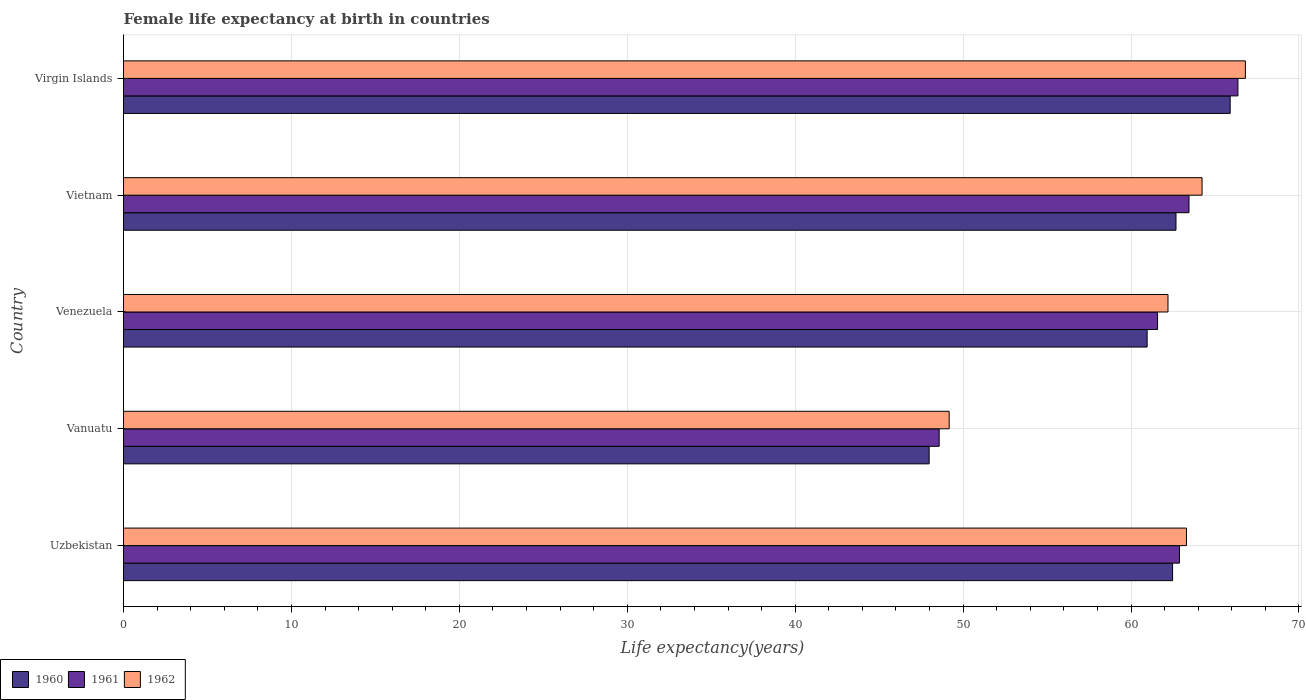How many different coloured bars are there?
Ensure brevity in your answer.  3. Are the number of bars per tick equal to the number of legend labels?
Offer a terse response. Yes. How many bars are there on the 3rd tick from the top?
Provide a short and direct response. 3. What is the label of the 1st group of bars from the top?
Offer a very short reply. Virgin Islands. What is the female life expectancy at birth in 1960 in Uzbekistan?
Make the answer very short. 62.48. Across all countries, what is the maximum female life expectancy at birth in 1962?
Give a very brief answer. 66.81. Across all countries, what is the minimum female life expectancy at birth in 1962?
Your response must be concise. 49.17. In which country was the female life expectancy at birth in 1960 maximum?
Offer a very short reply. Virgin Islands. In which country was the female life expectancy at birth in 1960 minimum?
Your answer should be very brief. Vanuatu. What is the total female life expectancy at birth in 1962 in the graph?
Your answer should be very brief. 305.72. What is the difference between the female life expectancy at birth in 1960 in Uzbekistan and that in Vanuatu?
Your response must be concise. 14.5. What is the difference between the female life expectancy at birth in 1961 in Vietnam and the female life expectancy at birth in 1962 in Uzbekistan?
Provide a succinct answer. 0.15. What is the average female life expectancy at birth in 1962 per country?
Offer a terse response. 61.14. What is the difference between the female life expectancy at birth in 1960 and female life expectancy at birth in 1961 in Venezuela?
Ensure brevity in your answer.  -0.62. In how many countries, is the female life expectancy at birth in 1961 greater than 62 years?
Offer a terse response. 3. What is the ratio of the female life expectancy at birth in 1962 in Vanuatu to that in Venezuela?
Your answer should be very brief. 0.79. Is the difference between the female life expectancy at birth in 1960 in Uzbekistan and Vietnam greater than the difference between the female life expectancy at birth in 1961 in Uzbekistan and Vietnam?
Offer a terse response. Yes. What is the difference between the highest and the second highest female life expectancy at birth in 1960?
Your answer should be very brief. 3.23. What is the difference between the highest and the lowest female life expectancy at birth in 1961?
Your response must be concise. 17.79. In how many countries, is the female life expectancy at birth in 1960 greater than the average female life expectancy at birth in 1960 taken over all countries?
Make the answer very short. 4. Is the sum of the female life expectancy at birth in 1960 in Venezuela and Virgin Islands greater than the maximum female life expectancy at birth in 1962 across all countries?
Make the answer very short. Yes. What does the 3rd bar from the top in Venezuela represents?
Offer a very short reply. 1960. Is it the case that in every country, the sum of the female life expectancy at birth in 1960 and female life expectancy at birth in 1961 is greater than the female life expectancy at birth in 1962?
Make the answer very short. Yes. How many bars are there?
Provide a succinct answer. 15. Are all the bars in the graph horizontal?
Offer a terse response. Yes. Are the values on the major ticks of X-axis written in scientific E-notation?
Provide a succinct answer. No. How are the legend labels stacked?
Make the answer very short. Horizontal. What is the title of the graph?
Give a very brief answer. Female life expectancy at birth in countries. What is the label or title of the X-axis?
Provide a short and direct response. Life expectancy(years). What is the label or title of the Y-axis?
Offer a very short reply. Country. What is the Life expectancy(years) of 1960 in Uzbekistan?
Your response must be concise. 62.48. What is the Life expectancy(years) in 1961 in Uzbekistan?
Your answer should be very brief. 62.89. What is the Life expectancy(years) of 1962 in Uzbekistan?
Make the answer very short. 63.3. What is the Life expectancy(years) of 1960 in Vanuatu?
Keep it short and to the point. 47.98. What is the Life expectancy(years) of 1961 in Vanuatu?
Your answer should be very brief. 48.58. What is the Life expectancy(years) in 1962 in Vanuatu?
Give a very brief answer. 49.17. What is the Life expectancy(years) of 1960 in Venezuela?
Provide a succinct answer. 60.96. What is the Life expectancy(years) of 1961 in Venezuela?
Your response must be concise. 61.58. What is the Life expectancy(years) of 1962 in Venezuela?
Offer a very short reply. 62.2. What is the Life expectancy(years) of 1960 in Vietnam?
Ensure brevity in your answer.  62.68. What is the Life expectancy(years) in 1961 in Vietnam?
Offer a terse response. 63.45. What is the Life expectancy(years) in 1962 in Vietnam?
Provide a succinct answer. 64.23. What is the Life expectancy(years) in 1960 in Virgin Islands?
Your answer should be compact. 65.91. What is the Life expectancy(years) of 1961 in Virgin Islands?
Ensure brevity in your answer.  66.37. What is the Life expectancy(years) in 1962 in Virgin Islands?
Your response must be concise. 66.81. Across all countries, what is the maximum Life expectancy(years) in 1960?
Make the answer very short. 65.91. Across all countries, what is the maximum Life expectancy(years) in 1961?
Provide a short and direct response. 66.37. Across all countries, what is the maximum Life expectancy(years) of 1962?
Make the answer very short. 66.81. Across all countries, what is the minimum Life expectancy(years) in 1960?
Give a very brief answer. 47.98. Across all countries, what is the minimum Life expectancy(years) of 1961?
Your response must be concise. 48.58. Across all countries, what is the minimum Life expectancy(years) in 1962?
Your answer should be compact. 49.17. What is the total Life expectancy(years) of 1960 in the graph?
Ensure brevity in your answer.  300. What is the total Life expectancy(years) in 1961 in the graph?
Offer a very short reply. 302.86. What is the total Life expectancy(years) of 1962 in the graph?
Offer a terse response. 305.72. What is the difference between the Life expectancy(years) in 1960 in Uzbekistan and that in Vanuatu?
Provide a short and direct response. 14.5. What is the difference between the Life expectancy(years) of 1961 in Uzbekistan and that in Vanuatu?
Your answer should be compact. 14.31. What is the difference between the Life expectancy(years) in 1962 in Uzbekistan and that in Vanuatu?
Provide a succinct answer. 14.13. What is the difference between the Life expectancy(years) in 1960 in Uzbekistan and that in Venezuela?
Your answer should be compact. 1.51. What is the difference between the Life expectancy(years) in 1961 in Uzbekistan and that in Venezuela?
Your answer should be very brief. 1.3. What is the difference between the Life expectancy(years) in 1962 in Uzbekistan and that in Venezuela?
Your answer should be very brief. 1.1. What is the difference between the Life expectancy(years) in 1960 in Uzbekistan and that in Vietnam?
Provide a short and direct response. -0.2. What is the difference between the Life expectancy(years) in 1961 in Uzbekistan and that in Vietnam?
Your response must be concise. -0.57. What is the difference between the Life expectancy(years) of 1962 in Uzbekistan and that in Vietnam?
Provide a short and direct response. -0.93. What is the difference between the Life expectancy(years) of 1960 in Uzbekistan and that in Virgin Islands?
Offer a terse response. -3.43. What is the difference between the Life expectancy(years) of 1961 in Uzbekistan and that in Virgin Islands?
Your answer should be very brief. -3.48. What is the difference between the Life expectancy(years) in 1962 in Uzbekistan and that in Virgin Islands?
Your answer should be compact. -3.51. What is the difference between the Life expectancy(years) in 1960 in Vanuatu and that in Venezuela?
Provide a short and direct response. -12.98. What is the difference between the Life expectancy(years) of 1961 in Vanuatu and that in Venezuela?
Provide a succinct answer. -13.01. What is the difference between the Life expectancy(years) of 1962 in Vanuatu and that in Venezuela?
Keep it short and to the point. -13.03. What is the difference between the Life expectancy(years) of 1960 in Vanuatu and that in Vietnam?
Your answer should be compact. -14.7. What is the difference between the Life expectancy(years) of 1961 in Vanuatu and that in Vietnam?
Make the answer very short. -14.88. What is the difference between the Life expectancy(years) of 1962 in Vanuatu and that in Vietnam?
Offer a terse response. -15.06. What is the difference between the Life expectancy(years) of 1960 in Vanuatu and that in Virgin Islands?
Offer a terse response. -17.93. What is the difference between the Life expectancy(years) of 1961 in Vanuatu and that in Virgin Islands?
Your response must be concise. -17.79. What is the difference between the Life expectancy(years) of 1962 in Vanuatu and that in Virgin Islands?
Your response must be concise. -17.64. What is the difference between the Life expectancy(years) of 1960 in Venezuela and that in Vietnam?
Your response must be concise. -1.72. What is the difference between the Life expectancy(years) of 1961 in Venezuela and that in Vietnam?
Make the answer very short. -1.87. What is the difference between the Life expectancy(years) in 1962 in Venezuela and that in Vietnam?
Ensure brevity in your answer.  -2.03. What is the difference between the Life expectancy(years) of 1960 in Venezuela and that in Virgin Islands?
Offer a terse response. -4.95. What is the difference between the Life expectancy(years) in 1961 in Venezuela and that in Virgin Islands?
Give a very brief answer. -4.79. What is the difference between the Life expectancy(years) of 1962 in Venezuela and that in Virgin Islands?
Offer a very short reply. -4.61. What is the difference between the Life expectancy(years) of 1960 in Vietnam and that in Virgin Islands?
Provide a succinct answer. -3.23. What is the difference between the Life expectancy(years) in 1961 in Vietnam and that in Virgin Islands?
Provide a short and direct response. -2.91. What is the difference between the Life expectancy(years) in 1962 in Vietnam and that in Virgin Islands?
Make the answer very short. -2.58. What is the difference between the Life expectancy(years) in 1960 in Uzbekistan and the Life expectancy(years) in 1961 in Vanuatu?
Provide a succinct answer. 13.9. What is the difference between the Life expectancy(years) of 1960 in Uzbekistan and the Life expectancy(years) of 1962 in Vanuatu?
Your answer should be compact. 13.3. What is the difference between the Life expectancy(years) in 1961 in Uzbekistan and the Life expectancy(years) in 1962 in Vanuatu?
Provide a succinct answer. 13.72. What is the difference between the Life expectancy(years) of 1960 in Uzbekistan and the Life expectancy(years) of 1961 in Venezuela?
Give a very brief answer. 0.89. What is the difference between the Life expectancy(years) of 1960 in Uzbekistan and the Life expectancy(years) of 1962 in Venezuela?
Your response must be concise. 0.27. What is the difference between the Life expectancy(years) of 1961 in Uzbekistan and the Life expectancy(years) of 1962 in Venezuela?
Offer a terse response. 0.69. What is the difference between the Life expectancy(years) in 1960 in Uzbekistan and the Life expectancy(years) in 1961 in Vietnam?
Keep it short and to the point. -0.98. What is the difference between the Life expectancy(years) in 1960 in Uzbekistan and the Life expectancy(years) in 1962 in Vietnam?
Keep it short and to the point. -1.76. What is the difference between the Life expectancy(years) of 1961 in Uzbekistan and the Life expectancy(years) of 1962 in Vietnam?
Your answer should be very brief. -1.34. What is the difference between the Life expectancy(years) in 1960 in Uzbekistan and the Life expectancy(years) in 1961 in Virgin Islands?
Offer a terse response. -3.89. What is the difference between the Life expectancy(years) in 1960 in Uzbekistan and the Life expectancy(years) in 1962 in Virgin Islands?
Offer a terse response. -4.34. What is the difference between the Life expectancy(years) of 1961 in Uzbekistan and the Life expectancy(years) of 1962 in Virgin Islands?
Provide a short and direct response. -3.92. What is the difference between the Life expectancy(years) in 1960 in Vanuatu and the Life expectancy(years) in 1961 in Venezuela?
Provide a short and direct response. -13.6. What is the difference between the Life expectancy(years) of 1960 in Vanuatu and the Life expectancy(years) of 1962 in Venezuela?
Your answer should be compact. -14.22. What is the difference between the Life expectancy(years) of 1961 in Vanuatu and the Life expectancy(years) of 1962 in Venezuela?
Keep it short and to the point. -13.63. What is the difference between the Life expectancy(years) of 1960 in Vanuatu and the Life expectancy(years) of 1961 in Vietnam?
Make the answer very short. -15.47. What is the difference between the Life expectancy(years) in 1960 in Vanuatu and the Life expectancy(years) in 1962 in Vietnam?
Your response must be concise. -16.25. What is the difference between the Life expectancy(years) in 1961 in Vanuatu and the Life expectancy(years) in 1962 in Vietnam?
Provide a succinct answer. -15.66. What is the difference between the Life expectancy(years) of 1960 in Vanuatu and the Life expectancy(years) of 1961 in Virgin Islands?
Your answer should be compact. -18.39. What is the difference between the Life expectancy(years) in 1960 in Vanuatu and the Life expectancy(years) in 1962 in Virgin Islands?
Offer a very short reply. -18.83. What is the difference between the Life expectancy(years) of 1961 in Vanuatu and the Life expectancy(years) of 1962 in Virgin Islands?
Provide a succinct answer. -18.24. What is the difference between the Life expectancy(years) of 1960 in Venezuela and the Life expectancy(years) of 1961 in Vietnam?
Keep it short and to the point. -2.49. What is the difference between the Life expectancy(years) in 1960 in Venezuela and the Life expectancy(years) in 1962 in Vietnam?
Provide a short and direct response. -3.27. What is the difference between the Life expectancy(years) in 1961 in Venezuela and the Life expectancy(years) in 1962 in Vietnam?
Ensure brevity in your answer.  -2.65. What is the difference between the Life expectancy(years) of 1960 in Venezuela and the Life expectancy(years) of 1961 in Virgin Islands?
Provide a succinct answer. -5.41. What is the difference between the Life expectancy(years) in 1960 in Venezuela and the Life expectancy(years) in 1962 in Virgin Islands?
Keep it short and to the point. -5.85. What is the difference between the Life expectancy(years) in 1961 in Venezuela and the Life expectancy(years) in 1962 in Virgin Islands?
Give a very brief answer. -5.23. What is the difference between the Life expectancy(years) of 1960 in Vietnam and the Life expectancy(years) of 1961 in Virgin Islands?
Give a very brief answer. -3.69. What is the difference between the Life expectancy(years) in 1960 in Vietnam and the Life expectancy(years) in 1962 in Virgin Islands?
Make the answer very short. -4.13. What is the difference between the Life expectancy(years) in 1961 in Vietnam and the Life expectancy(years) in 1962 in Virgin Islands?
Give a very brief answer. -3.36. What is the average Life expectancy(years) of 1960 per country?
Provide a succinct answer. 60. What is the average Life expectancy(years) in 1961 per country?
Make the answer very short. 60.57. What is the average Life expectancy(years) in 1962 per country?
Provide a succinct answer. 61.14. What is the difference between the Life expectancy(years) of 1960 and Life expectancy(years) of 1961 in Uzbekistan?
Your response must be concise. -0.41. What is the difference between the Life expectancy(years) of 1960 and Life expectancy(years) of 1962 in Uzbekistan?
Your answer should be very brief. -0.83. What is the difference between the Life expectancy(years) in 1961 and Life expectancy(years) in 1962 in Uzbekistan?
Your response must be concise. -0.42. What is the difference between the Life expectancy(years) in 1960 and Life expectancy(years) in 1961 in Vanuatu?
Provide a short and direct response. -0.6. What is the difference between the Life expectancy(years) in 1960 and Life expectancy(years) in 1962 in Vanuatu?
Make the answer very short. -1.19. What is the difference between the Life expectancy(years) of 1961 and Life expectancy(years) of 1962 in Vanuatu?
Your answer should be very brief. -0.6. What is the difference between the Life expectancy(years) in 1960 and Life expectancy(years) in 1961 in Venezuela?
Provide a short and direct response. -0.62. What is the difference between the Life expectancy(years) in 1960 and Life expectancy(years) in 1962 in Venezuela?
Offer a very short reply. -1.24. What is the difference between the Life expectancy(years) of 1961 and Life expectancy(years) of 1962 in Venezuela?
Keep it short and to the point. -0.62. What is the difference between the Life expectancy(years) in 1960 and Life expectancy(years) in 1961 in Vietnam?
Keep it short and to the point. -0.78. What is the difference between the Life expectancy(years) of 1960 and Life expectancy(years) of 1962 in Vietnam?
Provide a succinct answer. -1.55. What is the difference between the Life expectancy(years) of 1961 and Life expectancy(years) of 1962 in Vietnam?
Your answer should be compact. -0.78. What is the difference between the Life expectancy(years) of 1960 and Life expectancy(years) of 1961 in Virgin Islands?
Your answer should be very brief. -0.46. What is the difference between the Life expectancy(years) of 1960 and Life expectancy(years) of 1962 in Virgin Islands?
Your response must be concise. -0.91. What is the difference between the Life expectancy(years) in 1961 and Life expectancy(years) in 1962 in Virgin Islands?
Make the answer very short. -0.45. What is the ratio of the Life expectancy(years) in 1960 in Uzbekistan to that in Vanuatu?
Make the answer very short. 1.3. What is the ratio of the Life expectancy(years) in 1961 in Uzbekistan to that in Vanuatu?
Offer a very short reply. 1.29. What is the ratio of the Life expectancy(years) in 1962 in Uzbekistan to that in Vanuatu?
Give a very brief answer. 1.29. What is the ratio of the Life expectancy(years) in 1960 in Uzbekistan to that in Venezuela?
Offer a very short reply. 1.02. What is the ratio of the Life expectancy(years) in 1961 in Uzbekistan to that in Venezuela?
Make the answer very short. 1.02. What is the ratio of the Life expectancy(years) of 1962 in Uzbekistan to that in Venezuela?
Provide a succinct answer. 1.02. What is the ratio of the Life expectancy(years) in 1962 in Uzbekistan to that in Vietnam?
Offer a terse response. 0.99. What is the ratio of the Life expectancy(years) of 1960 in Uzbekistan to that in Virgin Islands?
Keep it short and to the point. 0.95. What is the ratio of the Life expectancy(years) of 1961 in Uzbekistan to that in Virgin Islands?
Keep it short and to the point. 0.95. What is the ratio of the Life expectancy(years) of 1962 in Uzbekistan to that in Virgin Islands?
Offer a terse response. 0.95. What is the ratio of the Life expectancy(years) in 1960 in Vanuatu to that in Venezuela?
Your response must be concise. 0.79. What is the ratio of the Life expectancy(years) in 1961 in Vanuatu to that in Venezuela?
Offer a very short reply. 0.79. What is the ratio of the Life expectancy(years) in 1962 in Vanuatu to that in Venezuela?
Provide a succinct answer. 0.79. What is the ratio of the Life expectancy(years) in 1960 in Vanuatu to that in Vietnam?
Give a very brief answer. 0.77. What is the ratio of the Life expectancy(years) of 1961 in Vanuatu to that in Vietnam?
Keep it short and to the point. 0.77. What is the ratio of the Life expectancy(years) in 1962 in Vanuatu to that in Vietnam?
Your answer should be compact. 0.77. What is the ratio of the Life expectancy(years) of 1960 in Vanuatu to that in Virgin Islands?
Your answer should be very brief. 0.73. What is the ratio of the Life expectancy(years) of 1961 in Vanuatu to that in Virgin Islands?
Your answer should be very brief. 0.73. What is the ratio of the Life expectancy(years) of 1962 in Vanuatu to that in Virgin Islands?
Your answer should be compact. 0.74. What is the ratio of the Life expectancy(years) in 1960 in Venezuela to that in Vietnam?
Your response must be concise. 0.97. What is the ratio of the Life expectancy(years) in 1961 in Venezuela to that in Vietnam?
Make the answer very short. 0.97. What is the ratio of the Life expectancy(years) in 1962 in Venezuela to that in Vietnam?
Keep it short and to the point. 0.97. What is the ratio of the Life expectancy(years) of 1960 in Venezuela to that in Virgin Islands?
Offer a very short reply. 0.93. What is the ratio of the Life expectancy(years) of 1961 in Venezuela to that in Virgin Islands?
Keep it short and to the point. 0.93. What is the ratio of the Life expectancy(years) of 1962 in Venezuela to that in Virgin Islands?
Give a very brief answer. 0.93. What is the ratio of the Life expectancy(years) of 1960 in Vietnam to that in Virgin Islands?
Your response must be concise. 0.95. What is the ratio of the Life expectancy(years) of 1961 in Vietnam to that in Virgin Islands?
Provide a short and direct response. 0.96. What is the ratio of the Life expectancy(years) in 1962 in Vietnam to that in Virgin Islands?
Keep it short and to the point. 0.96. What is the difference between the highest and the second highest Life expectancy(years) in 1960?
Make the answer very short. 3.23. What is the difference between the highest and the second highest Life expectancy(years) in 1961?
Make the answer very short. 2.91. What is the difference between the highest and the second highest Life expectancy(years) in 1962?
Offer a terse response. 2.58. What is the difference between the highest and the lowest Life expectancy(years) in 1960?
Keep it short and to the point. 17.93. What is the difference between the highest and the lowest Life expectancy(years) of 1961?
Offer a very short reply. 17.79. What is the difference between the highest and the lowest Life expectancy(years) in 1962?
Your answer should be compact. 17.64. 